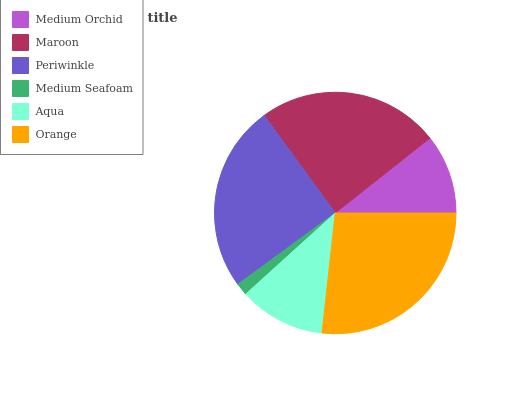Is Medium Seafoam the minimum?
Answer yes or no. Yes. Is Orange the maximum?
Answer yes or no. Yes. Is Maroon the minimum?
Answer yes or no. No. Is Maroon the maximum?
Answer yes or no. No. Is Maroon greater than Medium Orchid?
Answer yes or no. Yes. Is Medium Orchid less than Maroon?
Answer yes or no. Yes. Is Medium Orchid greater than Maroon?
Answer yes or no. No. Is Maroon less than Medium Orchid?
Answer yes or no. No. Is Maroon the high median?
Answer yes or no. Yes. Is Aqua the low median?
Answer yes or no. Yes. Is Aqua the high median?
Answer yes or no. No. Is Maroon the low median?
Answer yes or no. No. 